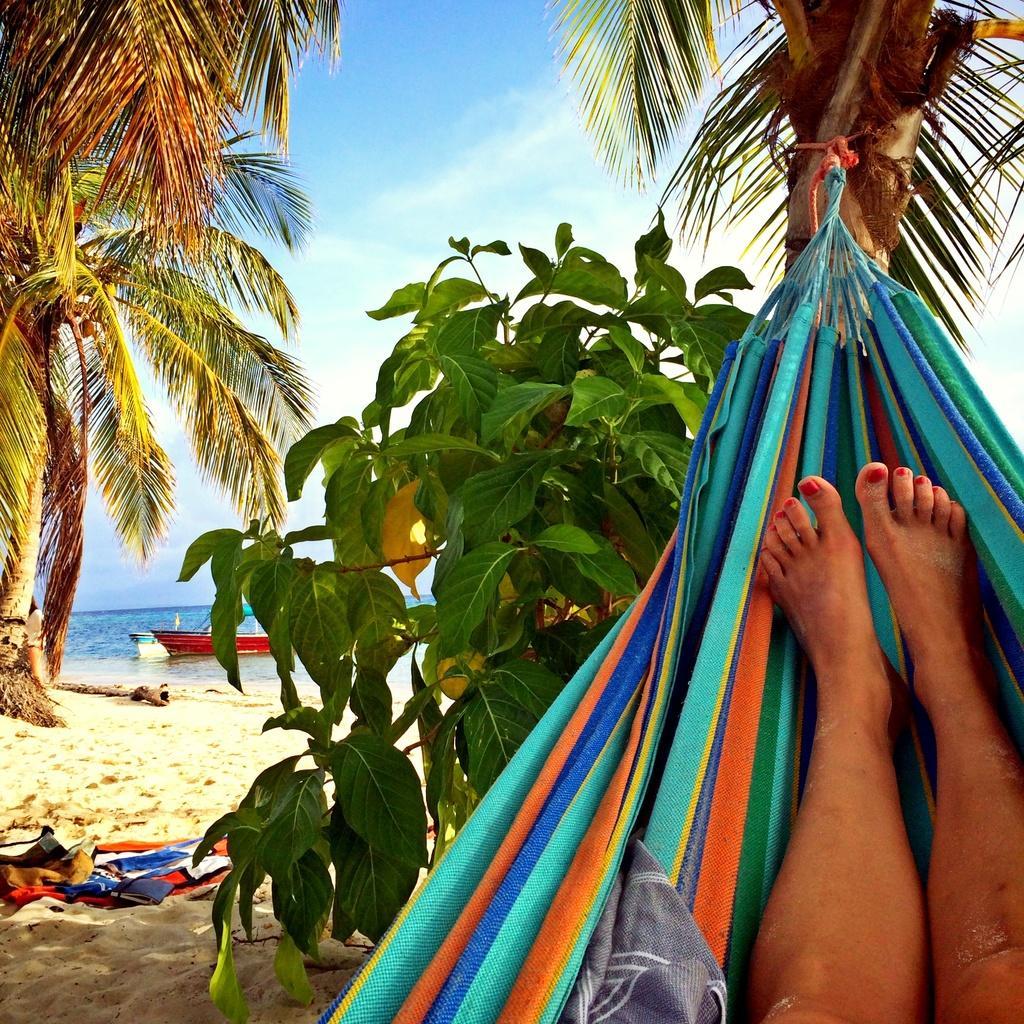How would you summarize this image in a sentence or two? On the right side we can see a hammock tied with a tree. We can see a person's legs in that. In the back there are trees and sand. In the background there is water. In that there are boats. Also there is sky in the background. On the sand there are some items. 